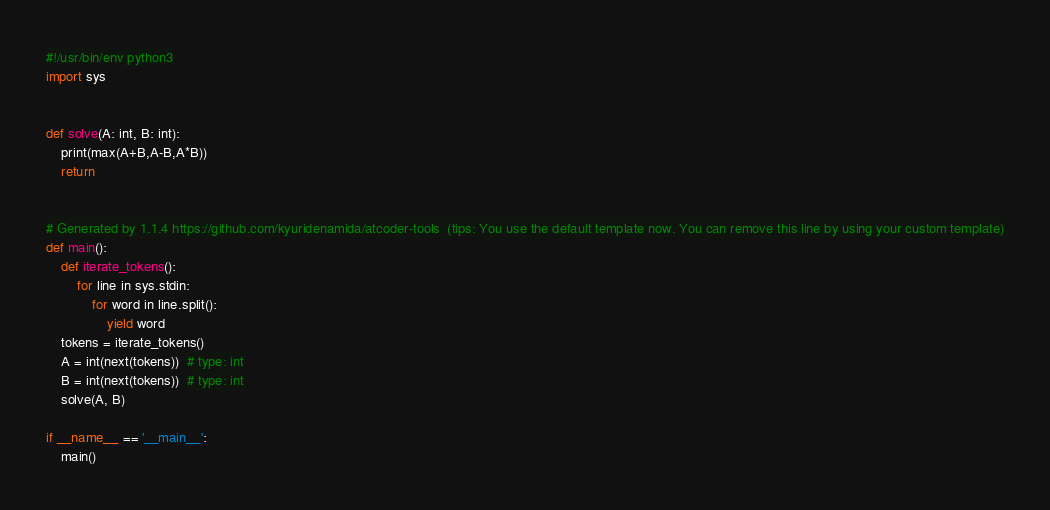<code> <loc_0><loc_0><loc_500><loc_500><_Python_>#!/usr/bin/env python3
import sys


def solve(A: int, B: int):
    print(max(A+B,A-B,A*B))
    return


# Generated by 1.1.4 https://github.com/kyuridenamida/atcoder-tools  (tips: You use the default template now. You can remove this line by using your custom template)
def main():
    def iterate_tokens():
        for line in sys.stdin:
            for word in line.split():
                yield word
    tokens = iterate_tokens()
    A = int(next(tokens))  # type: int
    B = int(next(tokens))  # type: int
    solve(A, B)

if __name__ == '__main__':
    main()
</code> 